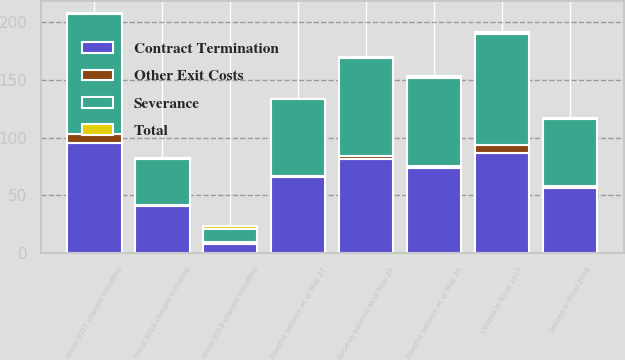Convert chart to OTSL. <chart><loc_0><loc_0><loc_500><loc_500><stacked_bar_chart><ecel><fcel>Reserve balance as of May 29<fcel>Fiscal 2017 charges including<fcel>Utilized in fiscal 2017<fcel>Reserve balance as of May 28<fcel>Fiscal 2018 charges including<fcel>Utilized in fiscal 2018<fcel>Reserve balance as of May 27<fcel>Fiscal 2019 charges including<nl><fcel>Contract Termination<fcel>73.6<fcel>95<fcel>86.8<fcel>81.8<fcel>40.8<fcel>56.6<fcel>66<fcel>7.7<nl><fcel>Total<fcel>1.5<fcel>0.9<fcel>1.7<fcel>0.7<fcel>0.2<fcel>0.8<fcel>0.1<fcel>2.5<nl><fcel>Other Exit Costs<fcel>1.5<fcel>8.1<fcel>7.1<fcel>2.5<fcel>0.7<fcel>1.1<fcel>0.7<fcel>1.4<nl><fcel>Severance<fcel>76.6<fcel>104<fcel>95.6<fcel>85<fcel>40.3<fcel>58.5<fcel>66.8<fcel>11.6<nl></chart> 